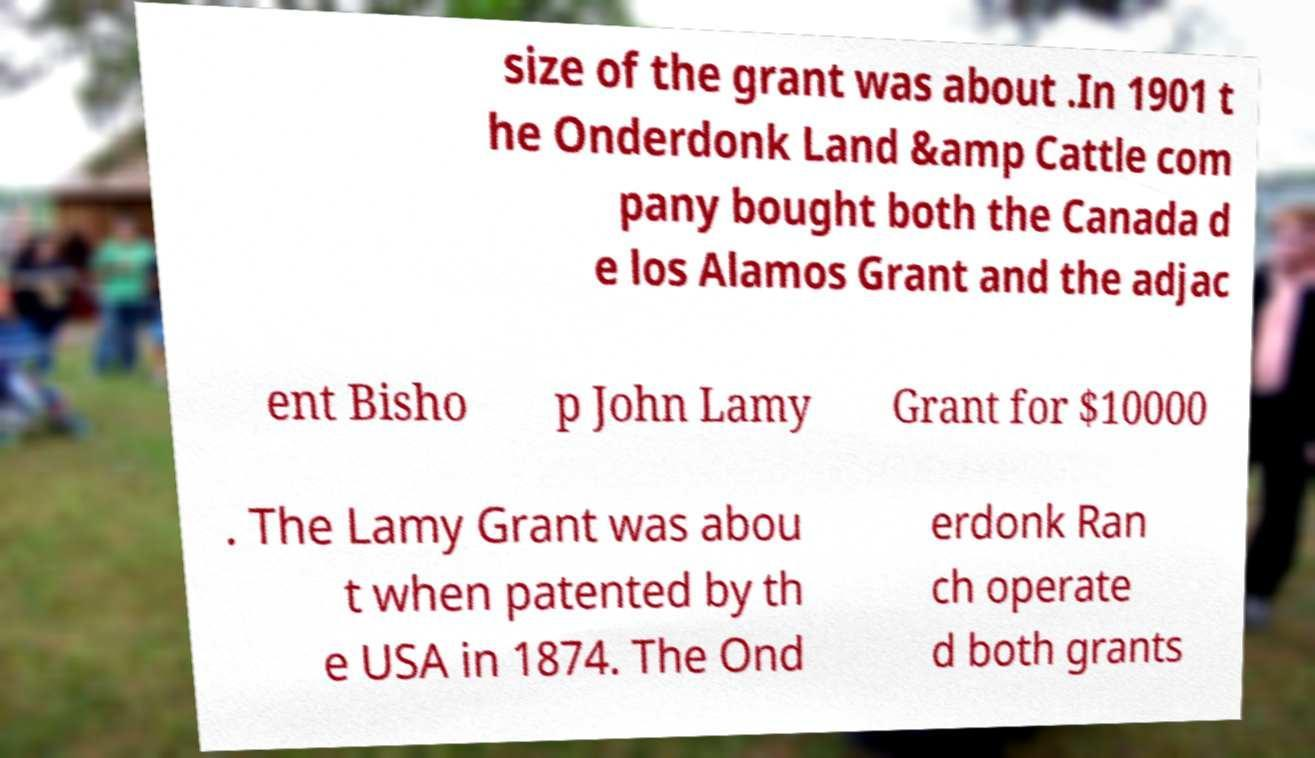Can you accurately transcribe the text from the provided image for me? size of the grant was about .In 1901 t he Onderdonk Land &amp Cattle com pany bought both the Canada d e los Alamos Grant and the adjac ent Bisho p John Lamy Grant for $10000 . The Lamy Grant was abou t when patented by th e USA in 1874. The Ond erdonk Ran ch operate d both grants 